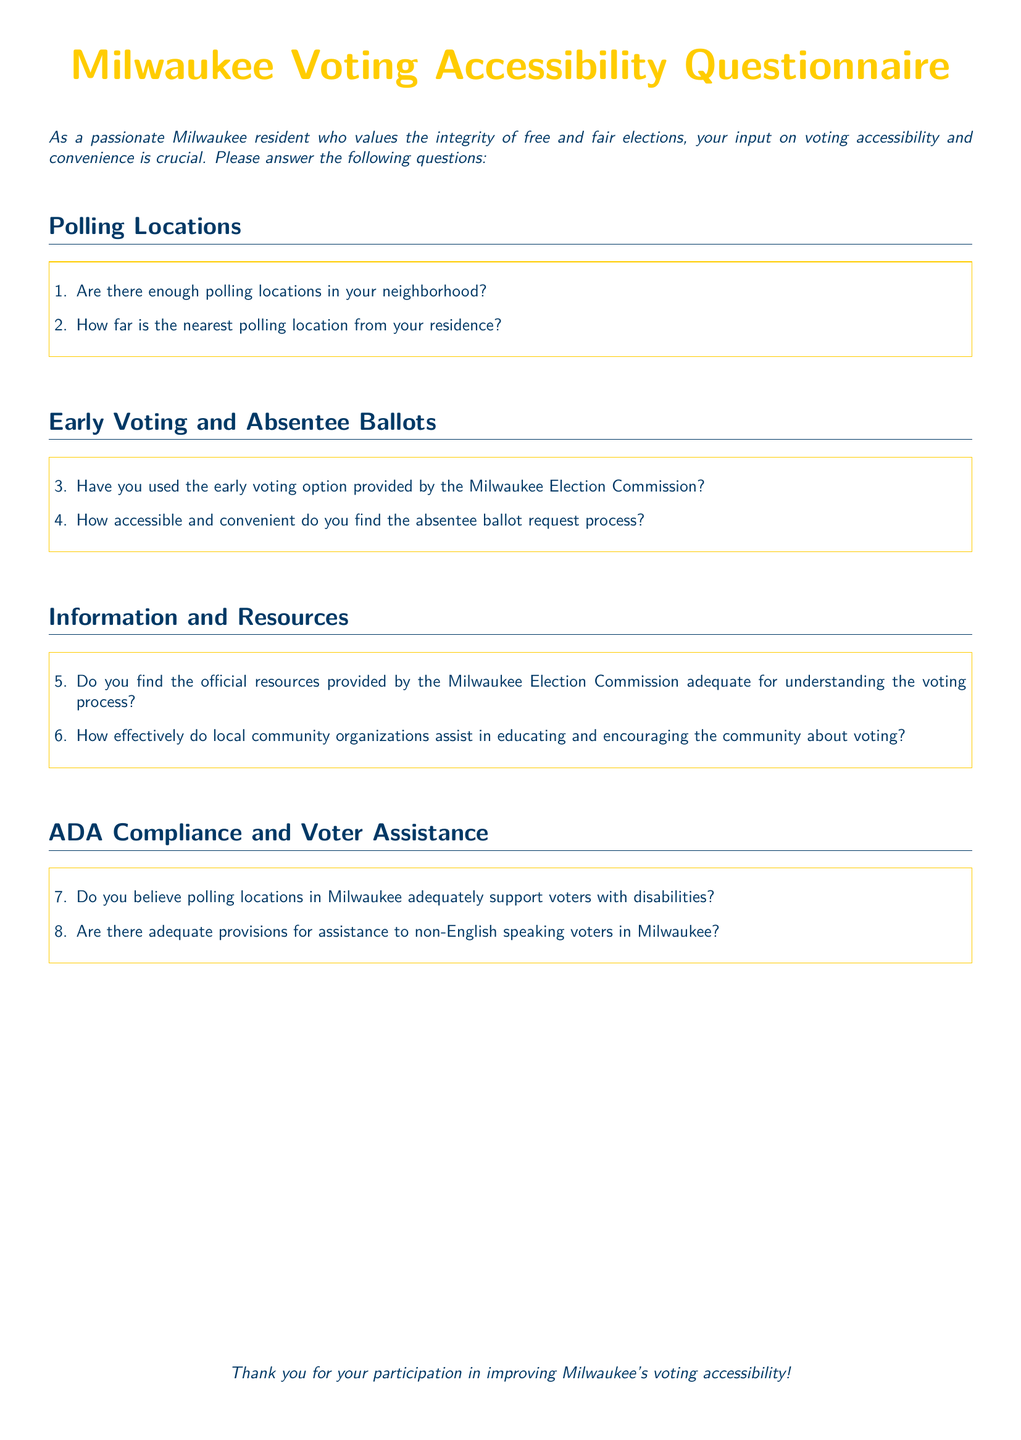What is the title of the document? The title of the document is centered at the top and highlighted, which is "Milwaukee Voting Accessibility Questionnaire."
Answer: Milwaukee Voting Accessibility Questionnaire How many sections are in the document? There are four distinct sections in the document: Polling Locations, Early Voting and Absentee Ballots, Information and Resources, and ADA Compliance and Voter Assistance.
Answer: 4 What color is used for the main text throughout the document? The color used for the main text is defined as "milwaukeeblue."
Answer: milwaukeeblue What is the first question regarding polling locations? The first question in the Polling Locations section asks if there are enough polling locations in the respondent's neighborhood.
Answer: Are there enough polling locations in your neighborhood? How does the document address voters with disabilities? The document includes a question asking whether polling locations in Milwaukee adequately support voters with disabilities in the ADA Compliance and Voter Assistance section.
Answer: Do you believe polling locations in Milwaukee adequately support voters with disabilities? What color is used for the question numbering? The question numbering is colored with "milwaukeeblue."
Answer: milwaukeeblue What is requested from the participants at the end of the document? The document concludes by thanking participants for their involvement in improving Milwaukee's voting accessibility.
Answer: Thank you for your participation in improving Milwaukee's voting accessibility! 